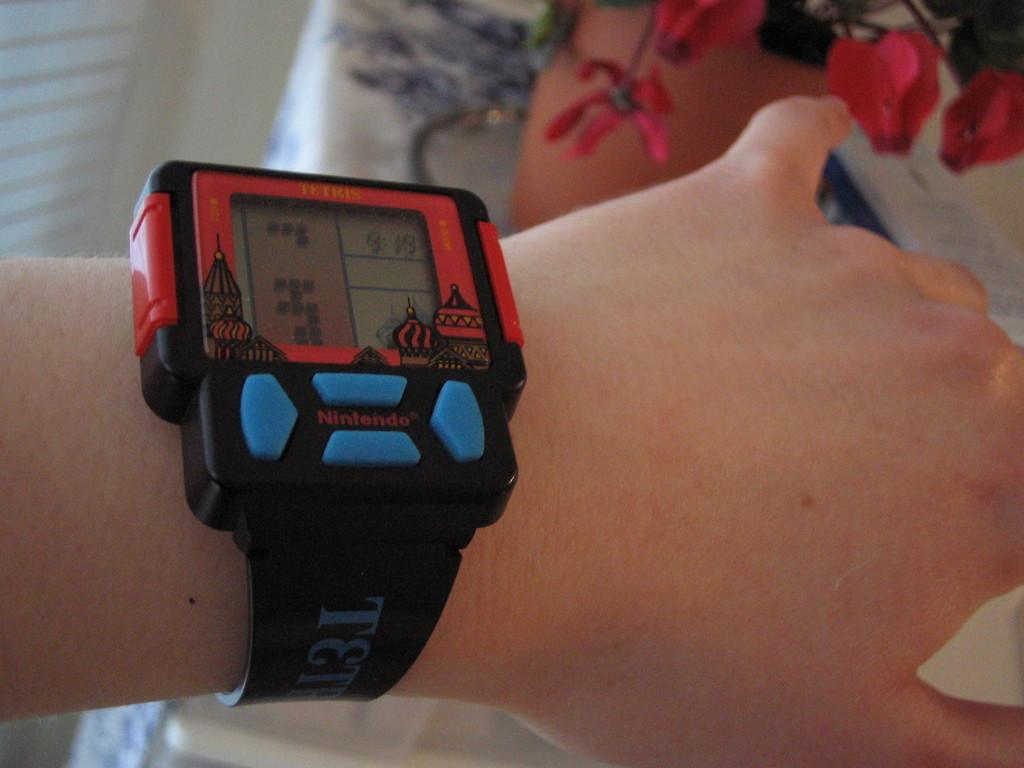<image>
Present a compact description of the photo's key features. A red and blue Tetris wristwatch by Nintendo. 